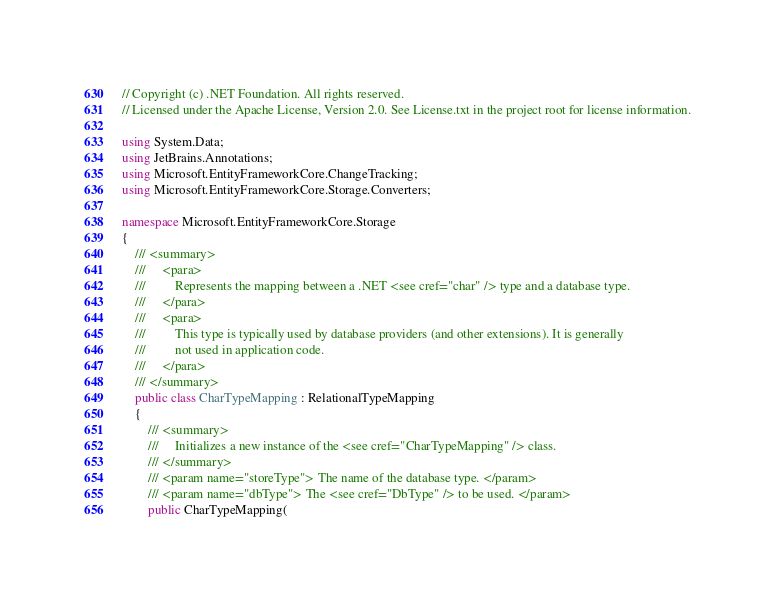<code> <loc_0><loc_0><loc_500><loc_500><_C#_>// Copyright (c) .NET Foundation. All rights reserved.
// Licensed under the Apache License, Version 2.0. See License.txt in the project root for license information.

using System.Data;
using JetBrains.Annotations;
using Microsoft.EntityFrameworkCore.ChangeTracking;
using Microsoft.EntityFrameworkCore.Storage.Converters;

namespace Microsoft.EntityFrameworkCore.Storage
{
    /// <summary>
    ///     <para>
    ///         Represents the mapping between a .NET <see cref="char" /> type and a database type.
    ///     </para>
    ///     <para>
    ///         This type is typically used by database providers (and other extensions). It is generally
    ///         not used in application code.
    ///     </para>
    /// </summary>
    public class CharTypeMapping : RelationalTypeMapping
    {
        /// <summary>
        ///     Initializes a new instance of the <see cref="CharTypeMapping" /> class.
        /// </summary>
        /// <param name="storeType"> The name of the database type. </param>
        /// <param name="dbType"> The <see cref="DbType" /> to be used. </param>
        public CharTypeMapping(</code> 